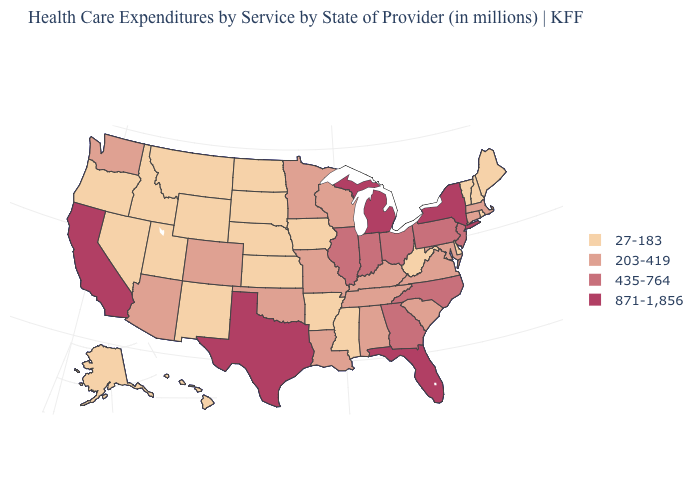Does the first symbol in the legend represent the smallest category?
Be succinct. Yes. How many symbols are there in the legend?
Keep it brief. 4. Is the legend a continuous bar?
Short answer required. No. What is the lowest value in the USA?
Write a very short answer. 27-183. Does North Dakota have the lowest value in the USA?
Answer briefly. Yes. Name the states that have a value in the range 871-1,856?
Keep it brief. California, Florida, Michigan, New York, Texas. Name the states that have a value in the range 435-764?
Short answer required. Georgia, Illinois, Indiana, New Jersey, North Carolina, Ohio, Pennsylvania. Does New York have the highest value in the Northeast?
Give a very brief answer. Yes. Which states have the lowest value in the USA?
Answer briefly. Alaska, Arkansas, Delaware, Hawaii, Idaho, Iowa, Kansas, Maine, Mississippi, Montana, Nebraska, Nevada, New Hampshire, New Mexico, North Dakota, Oregon, Rhode Island, South Dakota, Utah, Vermont, West Virginia, Wyoming. What is the highest value in states that border Montana?
Be succinct. 27-183. Is the legend a continuous bar?
Write a very short answer. No. Among the states that border New Mexico , which have the highest value?
Short answer required. Texas. What is the highest value in the USA?
Answer briefly. 871-1,856. Among the states that border Arizona , does California have the lowest value?
Answer briefly. No. Among the states that border Louisiana , does Texas have the lowest value?
Be succinct. No. 